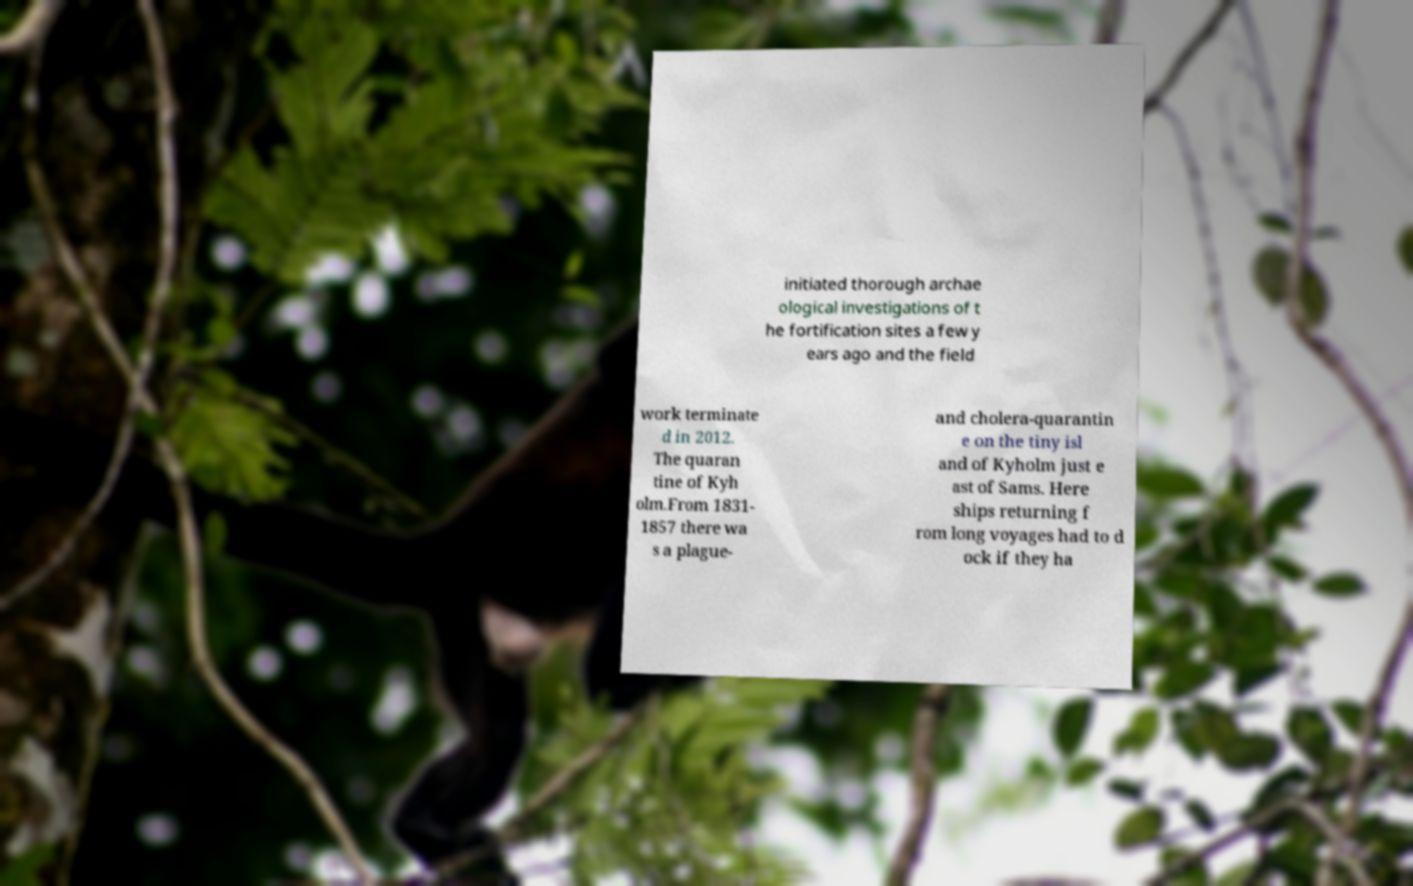Could you extract and type out the text from this image? initiated thorough archae ological investigations of t he fortification sites a few y ears ago and the field work terminate d in 2012. The quaran tine of Kyh olm.From 1831- 1857 there wa s a plague- and cholera-quarantin e on the tiny isl and of Kyholm just e ast of Sams. Here ships returning f rom long voyages had to d ock if they ha 